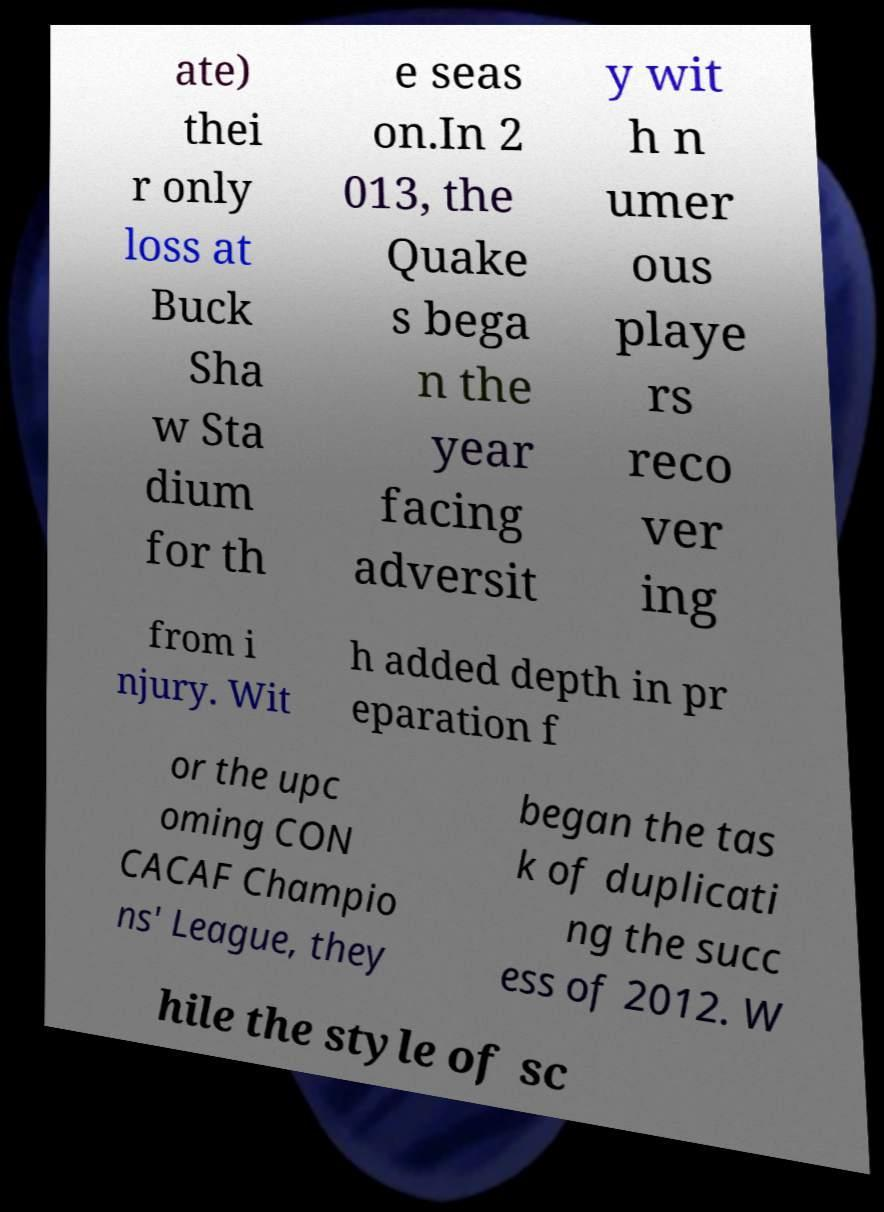Please identify and transcribe the text found in this image. ate) thei r only loss at Buck Sha w Sta dium for th e seas on.In 2 013, the Quake s bega n the year facing adversit y wit h n umer ous playe rs reco ver ing from i njury. Wit h added depth in pr eparation f or the upc oming CON CACAF Champio ns' League, they began the tas k of duplicati ng the succ ess of 2012. W hile the style of sc 